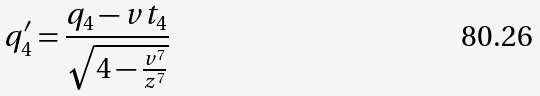<formula> <loc_0><loc_0><loc_500><loc_500>q _ { 4 } ^ { \prime } = \frac { q _ { 4 } - v t _ { 4 } } { \sqrt { 4 - \frac { v ^ { 7 } } { z ^ { 7 } } } }</formula> 